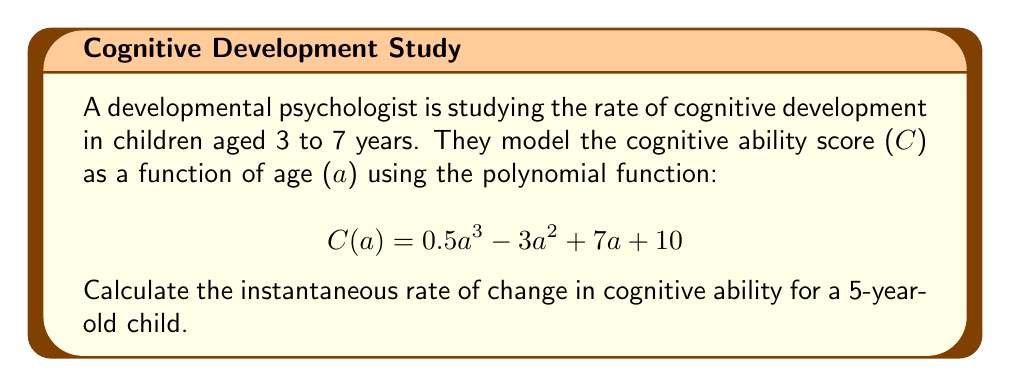Can you solve this math problem? To find the instantaneous rate of change in cognitive ability, we need to calculate the derivative of the given function $C(a)$ and then evaluate it at $a = 5$.

1. First, let's find the derivative of $C(a)$:
   
   $C(a) = 0.5a^3 - 3a^2 + 7a + 10$
   
   $C'(a) = \frac{d}{da}(0.5a^3 - 3a^2 + 7a + 10)$
   
   $C'(a) = 1.5a^2 - 6a + 7$

2. Now, we evaluate $C'(a)$ at $a = 5$:
   
   $C'(5) = 1.5(5)^2 - 6(5) + 7$
   
   $C'(5) = 1.5(25) - 30 + 7$
   
   $C'(5) = 37.5 - 30 + 7$
   
   $C'(5) = 14.5$

The instantaneous rate of change represents how quickly the cognitive ability score is changing at that specific age. A positive value indicates that the cognitive ability is increasing.
Answer: The instantaneous rate of change in cognitive ability for a 5-year-old child is 14.5 points per year. 